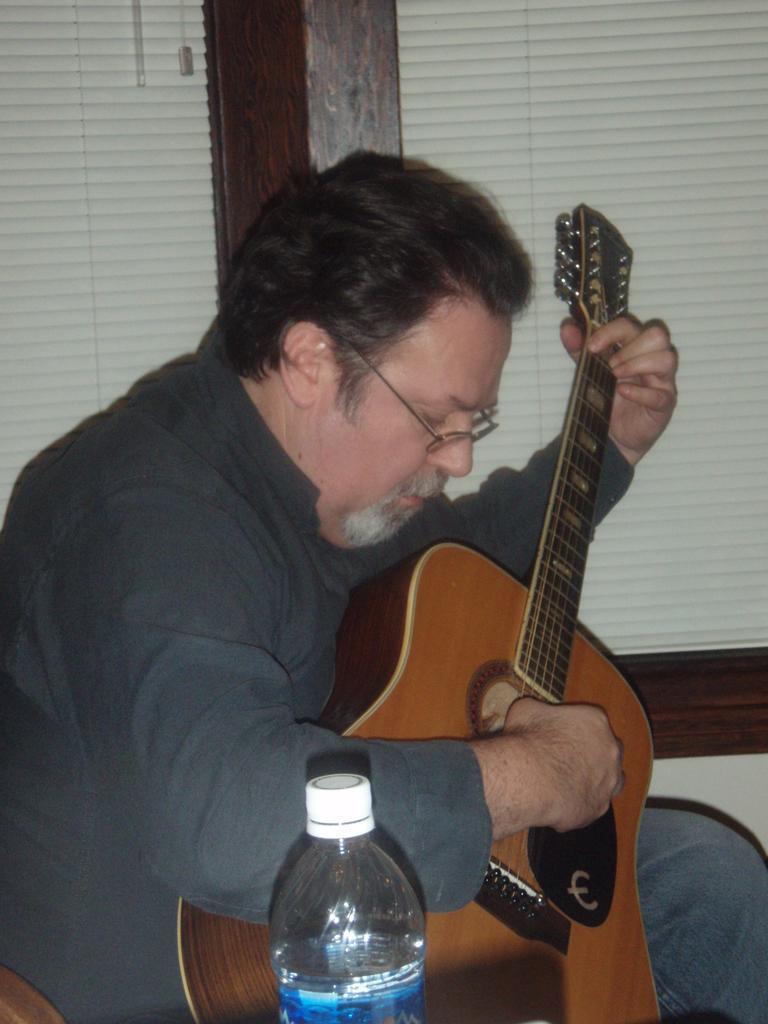Describe this image in one or two sentences. Here we can see a man siting and playing the guitar, and her is the bottle. 